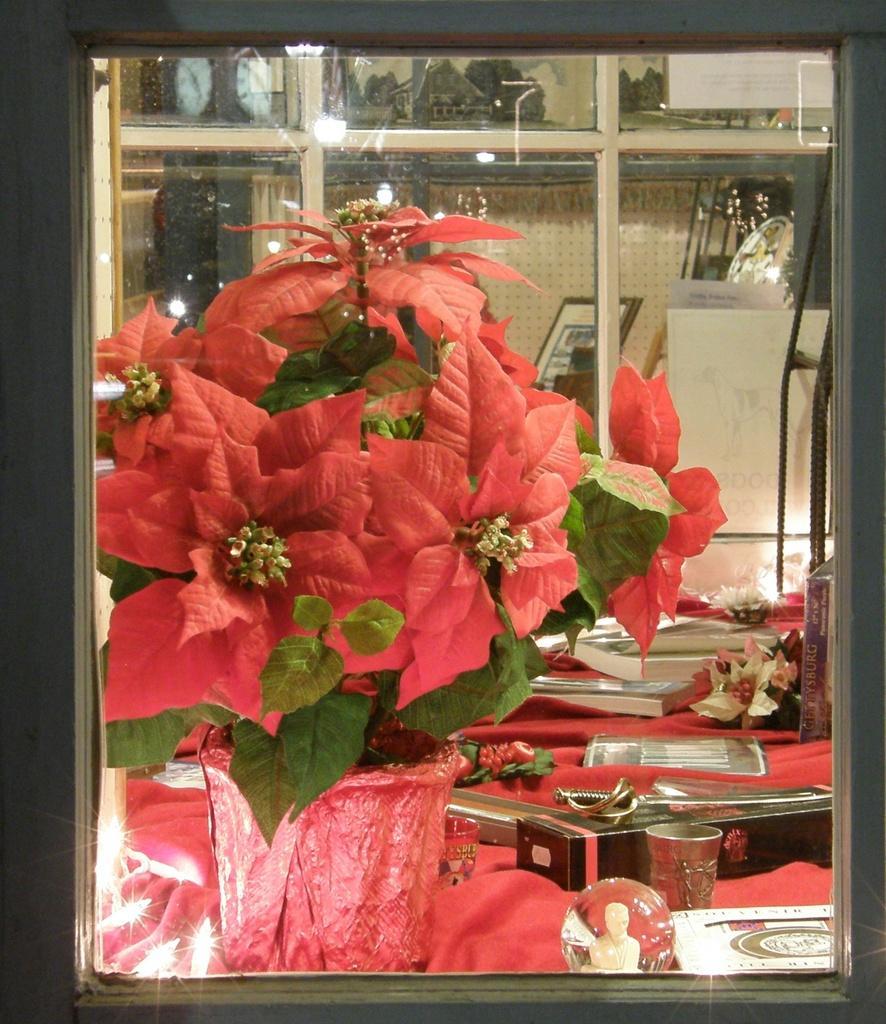Please provide a concise description of this image. In the center of the image there is a flower vase. In the background of the image there are many objects. There is a table on which there are many objects. 